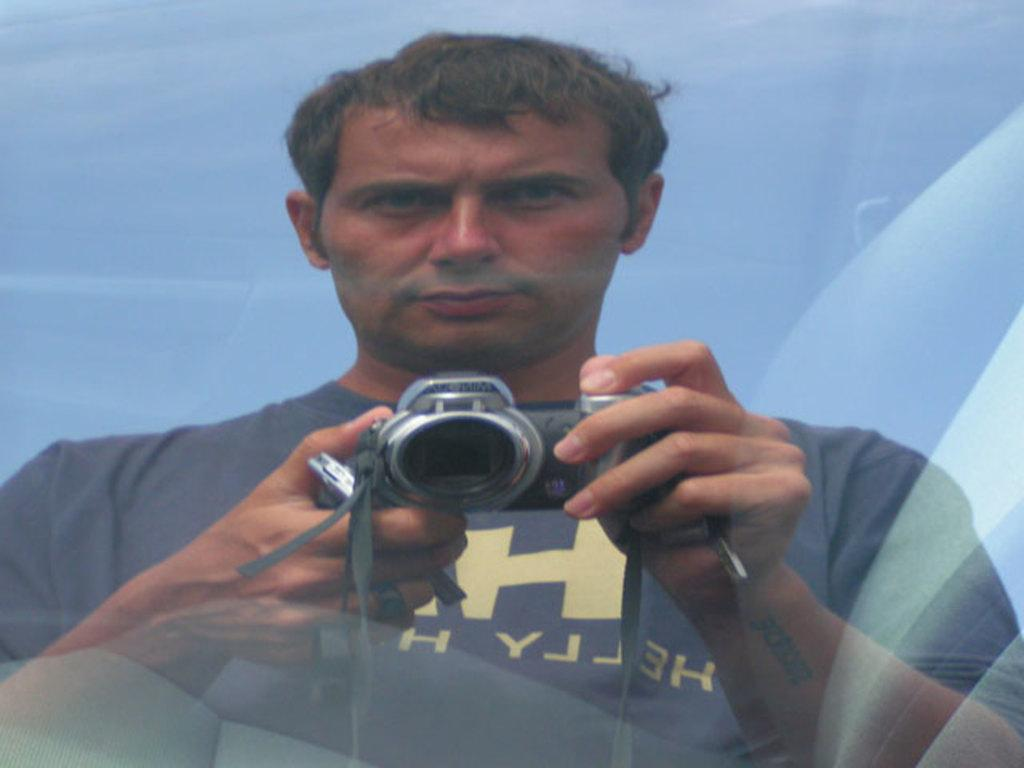What is the main subject of the image? There is a person in the image. What is the person doing in the image? The person is standing. What is the person holding in the image? The person is holding a camera in his hands. What type of destruction can be seen in the image? There is no destruction present in the image; it features a person standing and holding a camera. What kind of seed is being planted in the image? There is no seed or planting activity present in the image. 